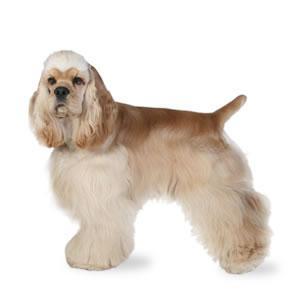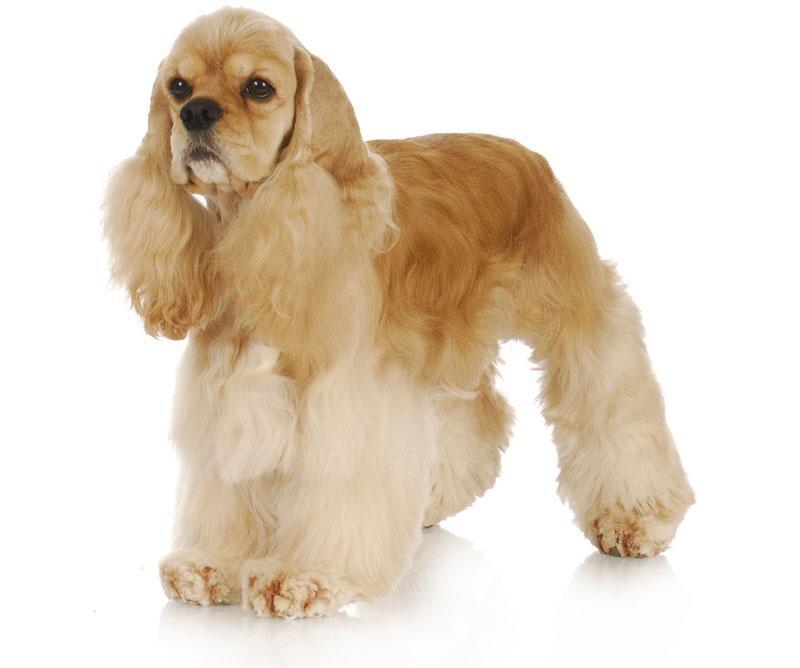The first image is the image on the left, the second image is the image on the right. Given the left and right images, does the statement "the dog in the image on the left is in side profile" hold true? Answer yes or no. Yes. The first image is the image on the left, the second image is the image on the right. Analyze the images presented: Is the assertion "There are two dogs standing and facing left." valid? Answer yes or no. Yes. 